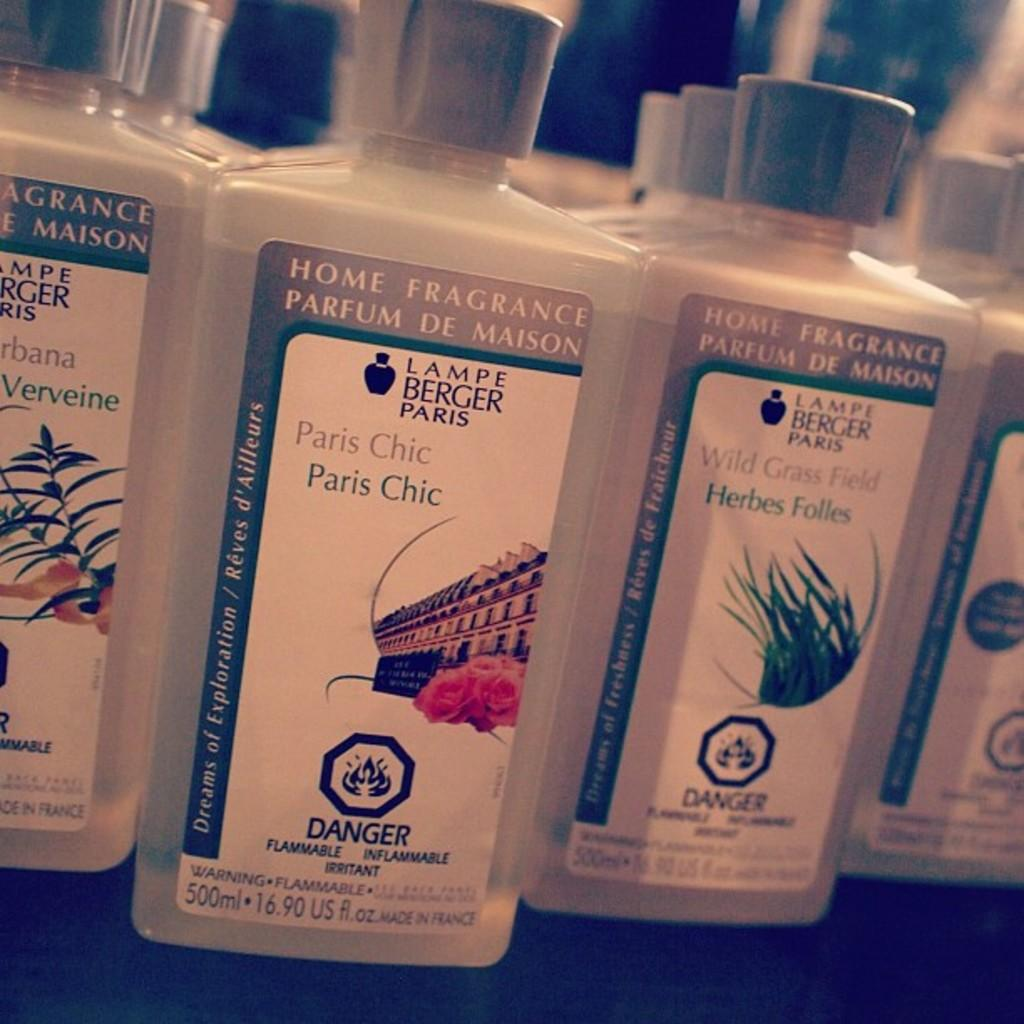<image>
Create a compact narrative representing the image presented. Bottles of perfume by Lampe Berger Paris called Paris Chic. 